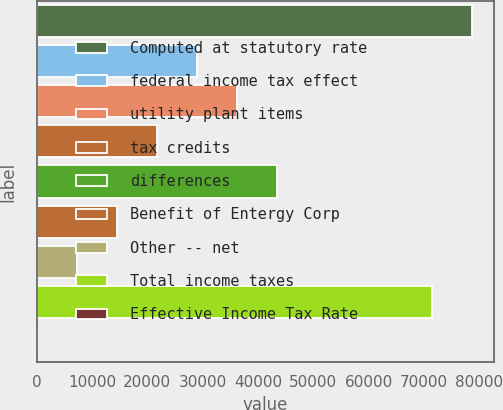<chart> <loc_0><loc_0><loc_500><loc_500><bar_chart><fcel>Computed at statutory rate<fcel>federal income tax effect<fcel>utility plant items<fcel>tax credits<fcel>differences<fcel>Benefit of Entergy Corp<fcel>Other -- net<fcel>Total income taxes<fcel>Effective Income Tax Rate<nl><fcel>78647.2<fcel>29007.5<fcel>36250.8<fcel>21764.2<fcel>43494<fcel>14521<fcel>7277.75<fcel>71404<fcel>34.5<nl></chart> 